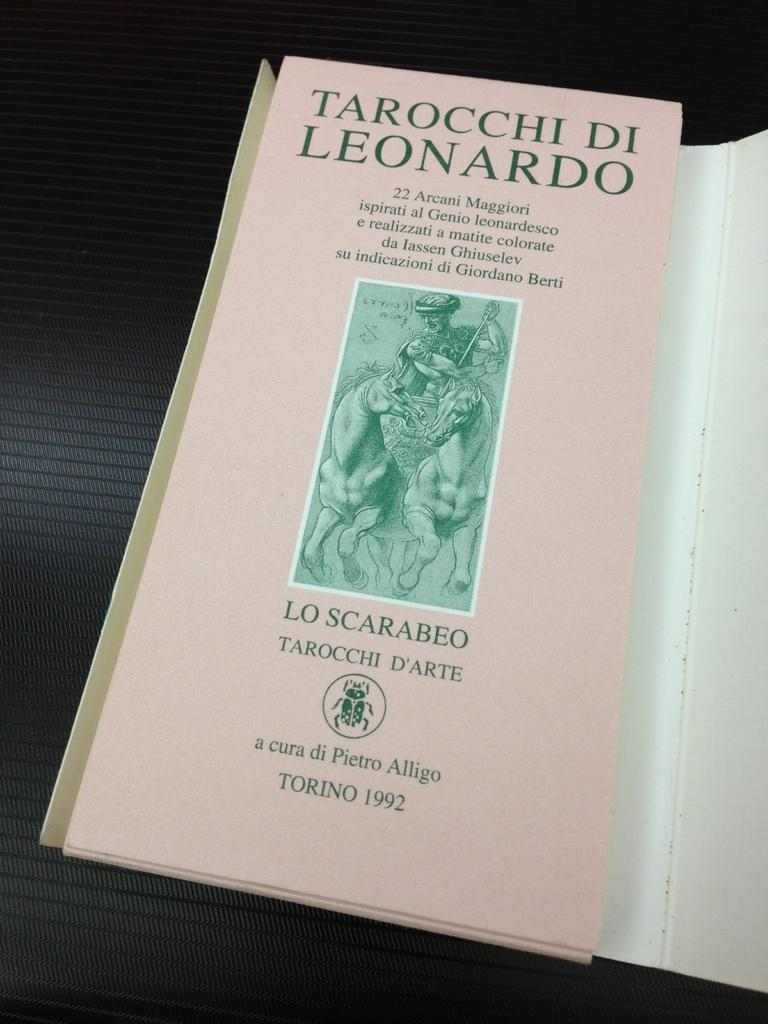Provide a one-sentence caption for the provided image. A pink book that isn't in English titled Tarocchi Di Leonardo. 